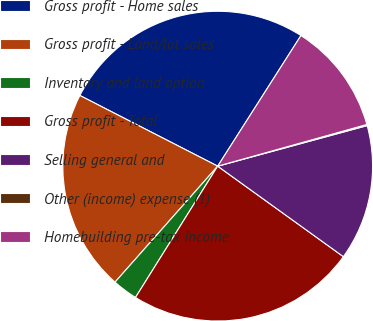Convert chart to OTSL. <chart><loc_0><loc_0><loc_500><loc_500><pie_chart><fcel>Gross profit - Home sales<fcel>Gross profit - Land/lot sales<fcel>Inventory and land option<fcel>Gross profit - Total<fcel>Selling general and<fcel>Other (income) expense (1)<fcel>Homebuilding pre-tax income<nl><fcel>26.49%<fcel>21.01%<fcel>2.63%<fcel>23.97%<fcel>14.15%<fcel>0.12%<fcel>11.63%<nl></chart> 